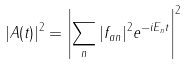<formula> <loc_0><loc_0><loc_500><loc_500>| A ( t ) | ^ { 2 } = \left | \sum _ { n } | f _ { a n } | ^ { 2 } e ^ { - i E _ { n } t } \right | ^ { 2 }</formula> 